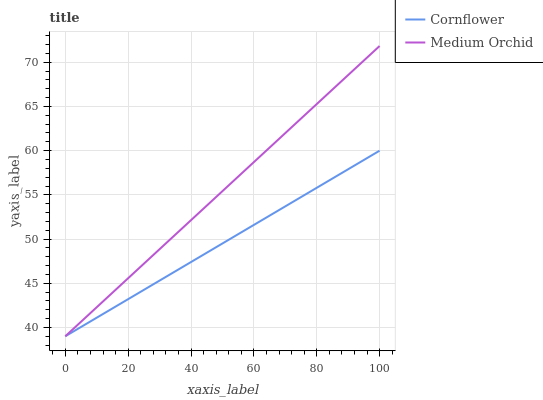Does Cornflower have the minimum area under the curve?
Answer yes or no. Yes. Does Medium Orchid have the maximum area under the curve?
Answer yes or no. Yes. Does Medium Orchid have the minimum area under the curve?
Answer yes or no. No. Is Cornflower the smoothest?
Answer yes or no. Yes. Is Medium Orchid the roughest?
Answer yes or no. Yes. Is Medium Orchid the smoothest?
Answer yes or no. No. Does Medium Orchid have the highest value?
Answer yes or no. Yes. Does Cornflower intersect Medium Orchid?
Answer yes or no. Yes. Is Cornflower less than Medium Orchid?
Answer yes or no. No. Is Cornflower greater than Medium Orchid?
Answer yes or no. No. 